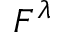<formula> <loc_0><loc_0><loc_500><loc_500>F ^ { \lambda }</formula> 